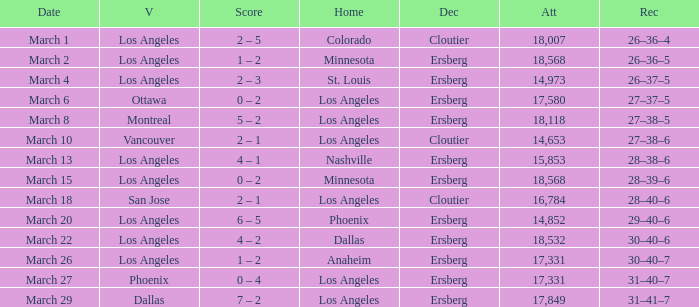What is the Decision listed when the Home was Colorado? Cloutier. Give me the full table as a dictionary. {'header': ['Date', 'V', 'Score', 'Home', 'Dec', 'Att', 'Rec'], 'rows': [['March 1', 'Los Angeles', '2 – 5', 'Colorado', 'Cloutier', '18,007', '26–36–4'], ['March 2', 'Los Angeles', '1 – 2', 'Minnesota', 'Ersberg', '18,568', '26–36–5'], ['March 4', 'Los Angeles', '2 – 3', 'St. Louis', 'Ersberg', '14,973', '26–37–5'], ['March 6', 'Ottawa', '0 – 2', 'Los Angeles', 'Ersberg', '17,580', '27–37–5'], ['March 8', 'Montreal', '5 – 2', 'Los Angeles', 'Ersberg', '18,118', '27–38–5'], ['March 10', 'Vancouver', '2 – 1', 'Los Angeles', 'Cloutier', '14,653', '27–38–6'], ['March 13', 'Los Angeles', '4 – 1', 'Nashville', 'Ersberg', '15,853', '28–38–6'], ['March 15', 'Los Angeles', '0 – 2', 'Minnesota', 'Ersberg', '18,568', '28–39–6'], ['March 18', 'San Jose', '2 – 1', 'Los Angeles', 'Cloutier', '16,784', '28–40–6'], ['March 20', 'Los Angeles', '6 – 5', 'Phoenix', 'Ersberg', '14,852', '29–40–6'], ['March 22', 'Los Angeles', '4 – 2', 'Dallas', 'Ersberg', '18,532', '30–40–6'], ['March 26', 'Los Angeles', '1 – 2', 'Anaheim', 'Ersberg', '17,331', '30–40–7'], ['March 27', 'Phoenix', '0 – 4', 'Los Angeles', 'Ersberg', '17,331', '31–40–7'], ['March 29', 'Dallas', '7 – 2', 'Los Angeles', 'Ersberg', '17,849', '31–41–7']]} 